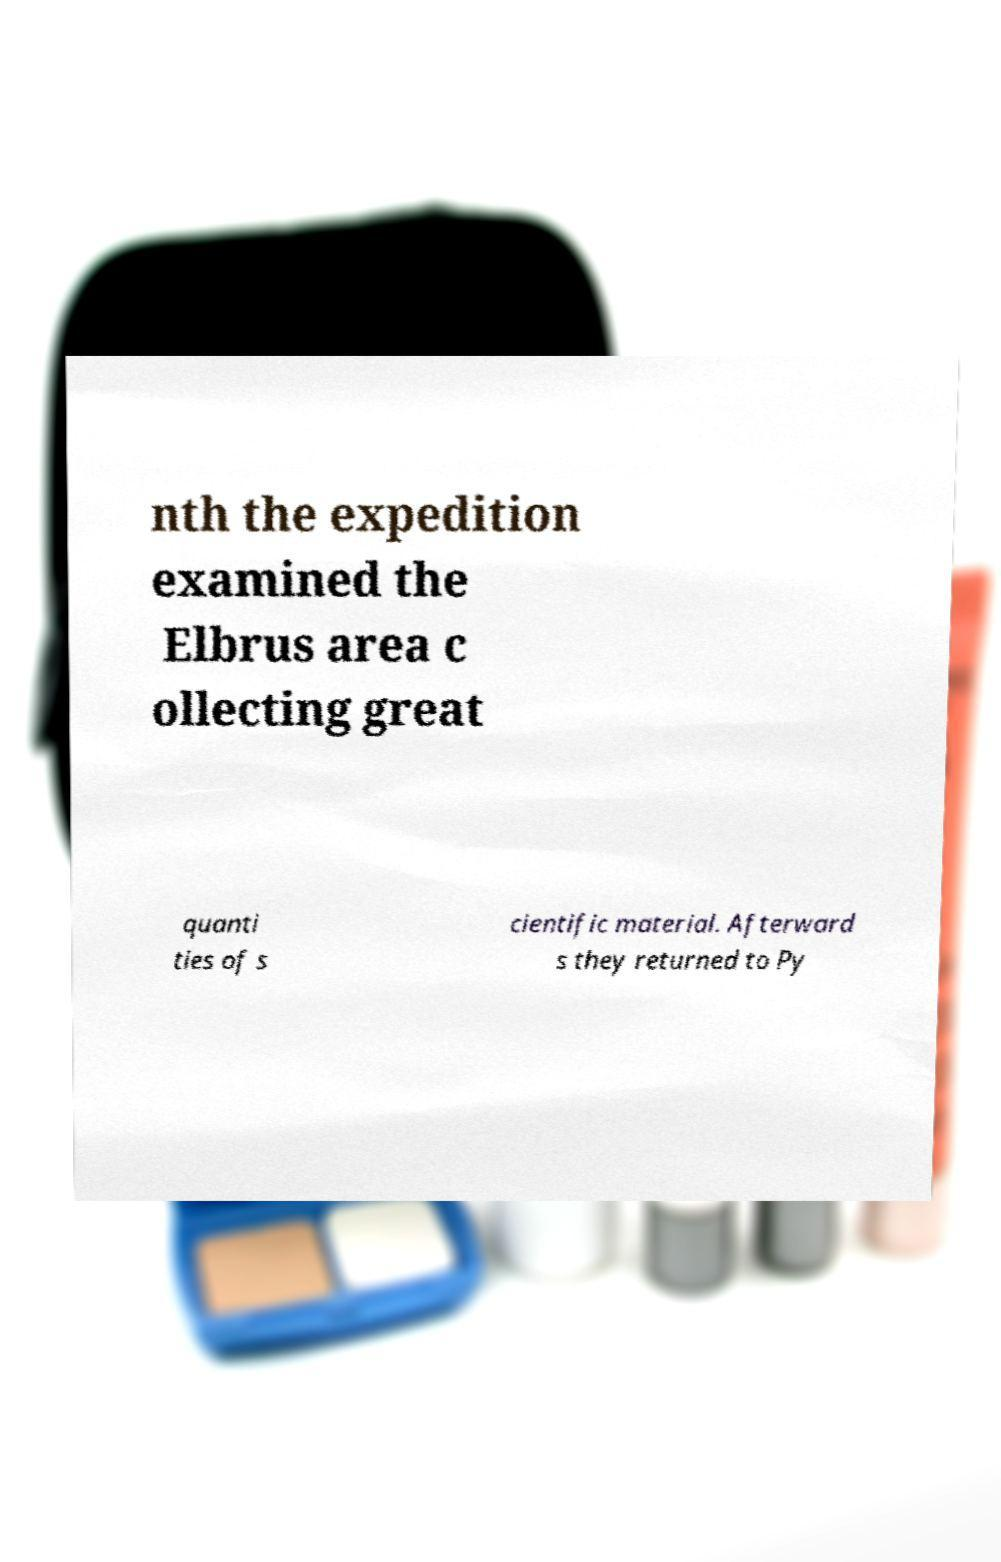There's text embedded in this image that I need extracted. Can you transcribe it verbatim? nth the expedition examined the Elbrus area c ollecting great quanti ties of s cientific material. Afterward s they returned to Py 